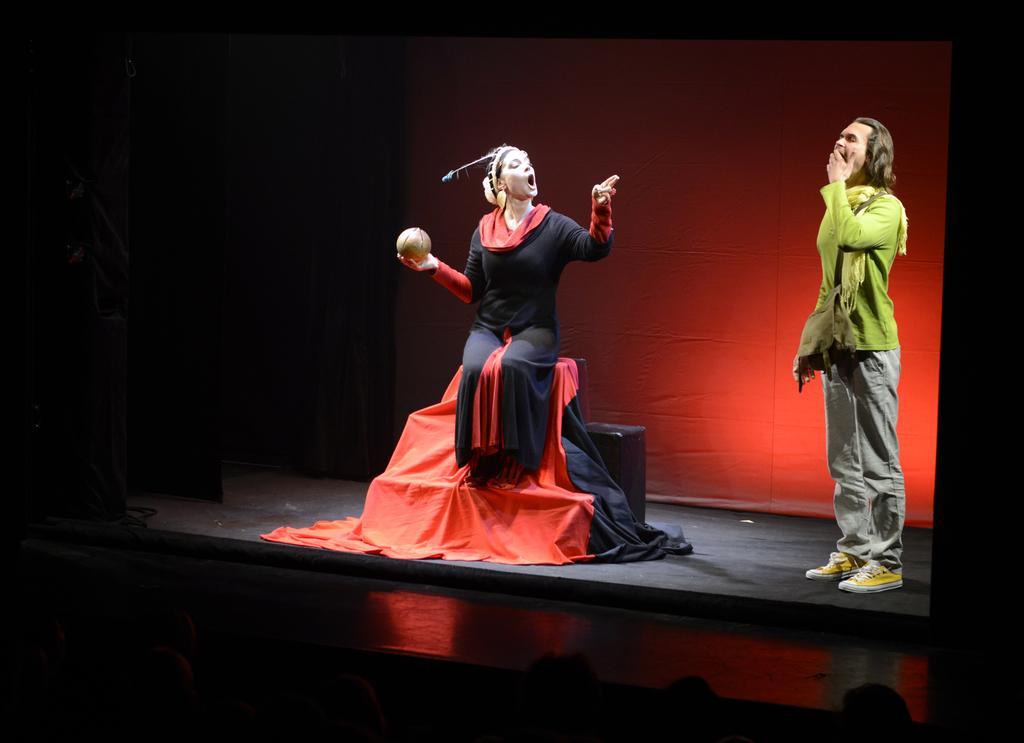Please provide a concise description of this image. In this image we can see there is a boy and a girl playing an act on the stage. 